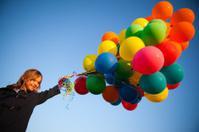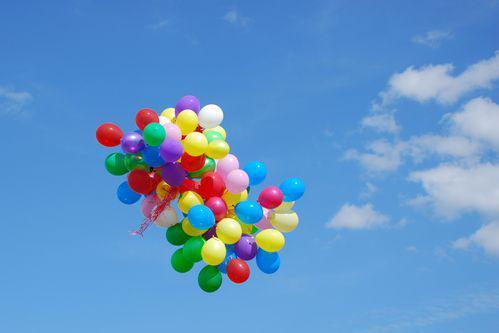The first image is the image on the left, the second image is the image on the right. Considering the images on both sides, is "Balloons are carrying an object up in the air." valid? Answer yes or no. No. The first image is the image on the left, the second image is the image on the right. Analyze the images presented: Is the assertion "There is at least one person holding balloons." valid? Answer yes or no. Yes. 